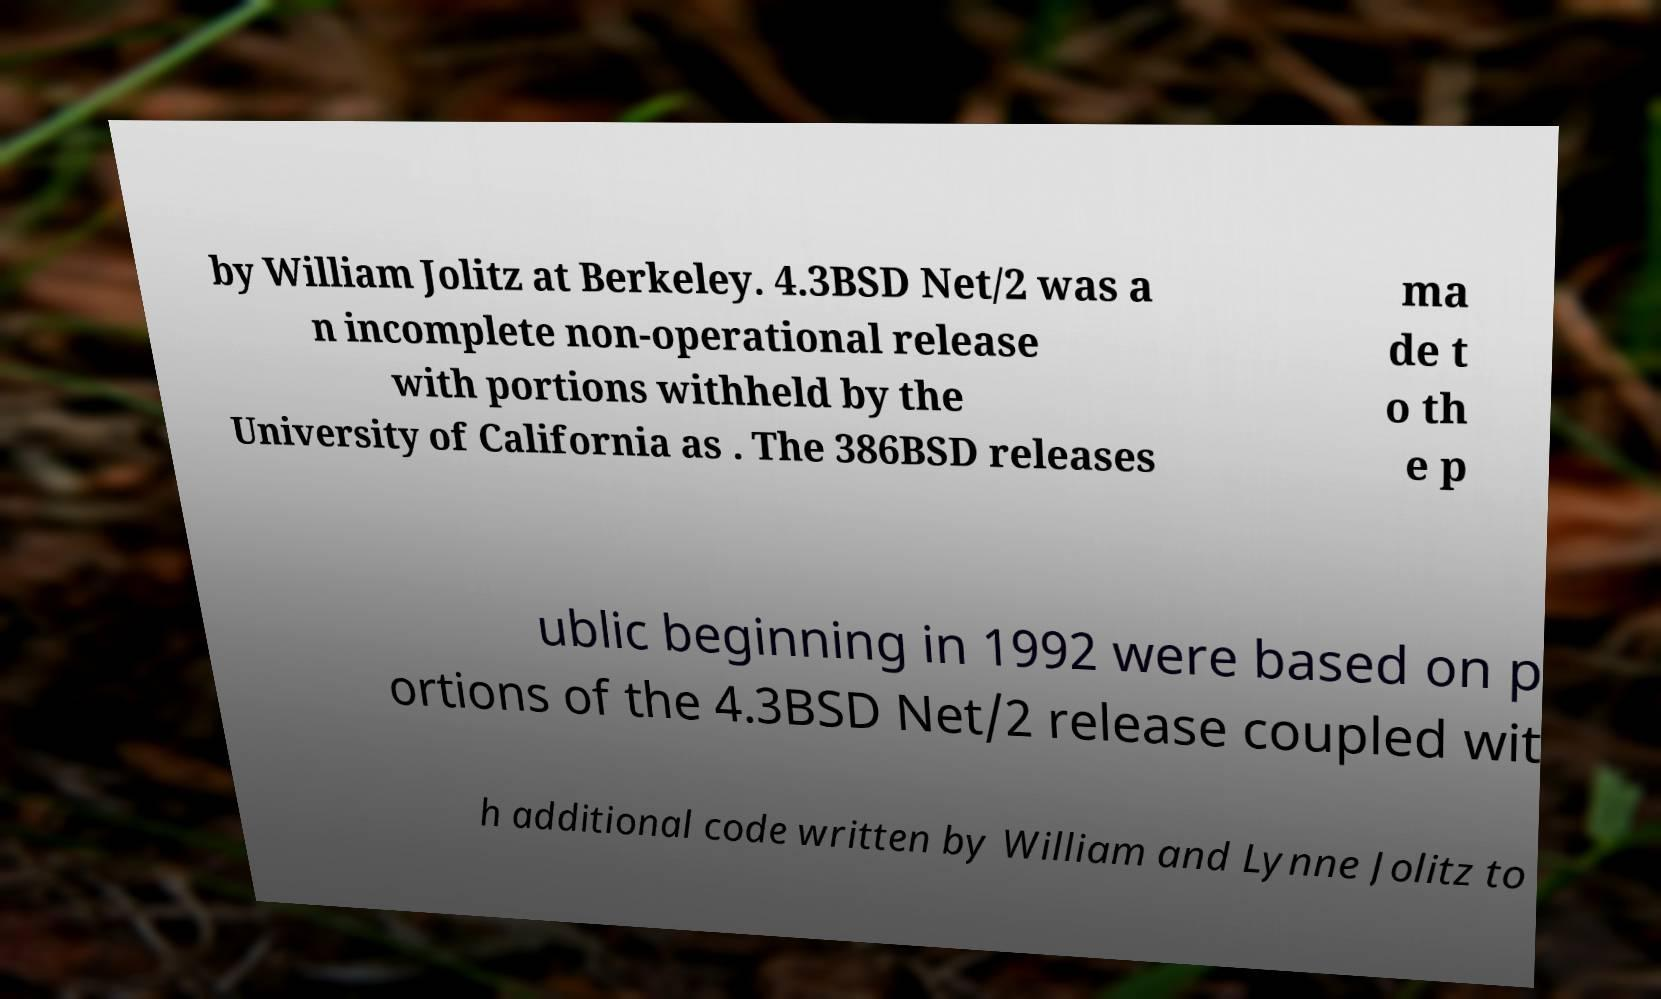What messages or text are displayed in this image? I need them in a readable, typed format. by William Jolitz at Berkeley. 4.3BSD Net/2 was a n incomplete non-operational release with portions withheld by the University of California as . The 386BSD releases ma de t o th e p ublic beginning in 1992 were based on p ortions of the 4.3BSD Net/2 release coupled wit h additional code written by William and Lynne Jolitz to 